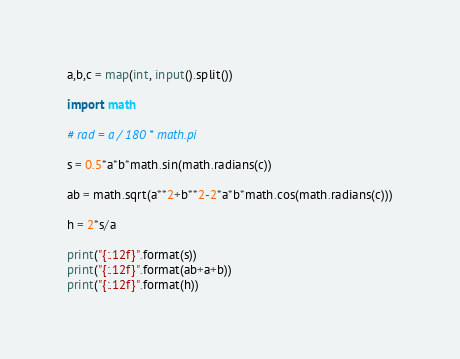<code> <loc_0><loc_0><loc_500><loc_500><_Python_>a,b,c = map(int, input().split())

import math

# rad = a / 180 * math.pi

s = 0.5*a*b*math.sin(math.radians(c))

ab = math.sqrt(a**2+b**2-2*a*b*math.cos(math.radians(c)))

h = 2*s/a

print("{:.12f}".format(s))
print("{:.12f}".format(ab+a+b))
print("{:.12f}".format(h))
</code> 